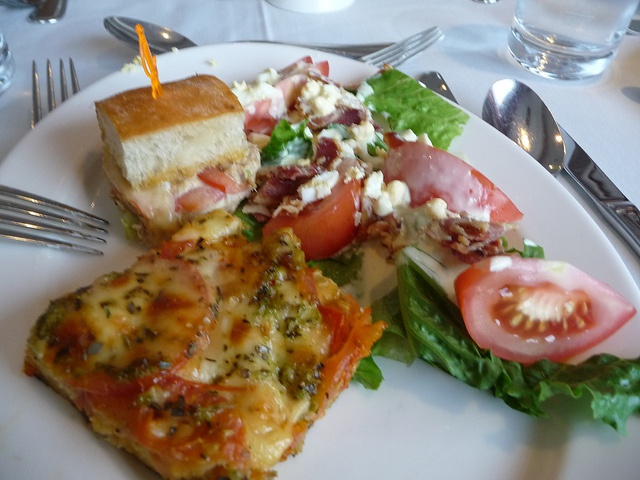Describe the objects in this image and their specific colors. I can see pizza in blue, maroon, olive, and tan tones, sandwich in blue, brown, lightgray, and tan tones, cup in blue, darkgray, lightblue, and white tones, spoon in blue, gray, white, and darkgray tones, and knife in blue, gray, and black tones in this image. 